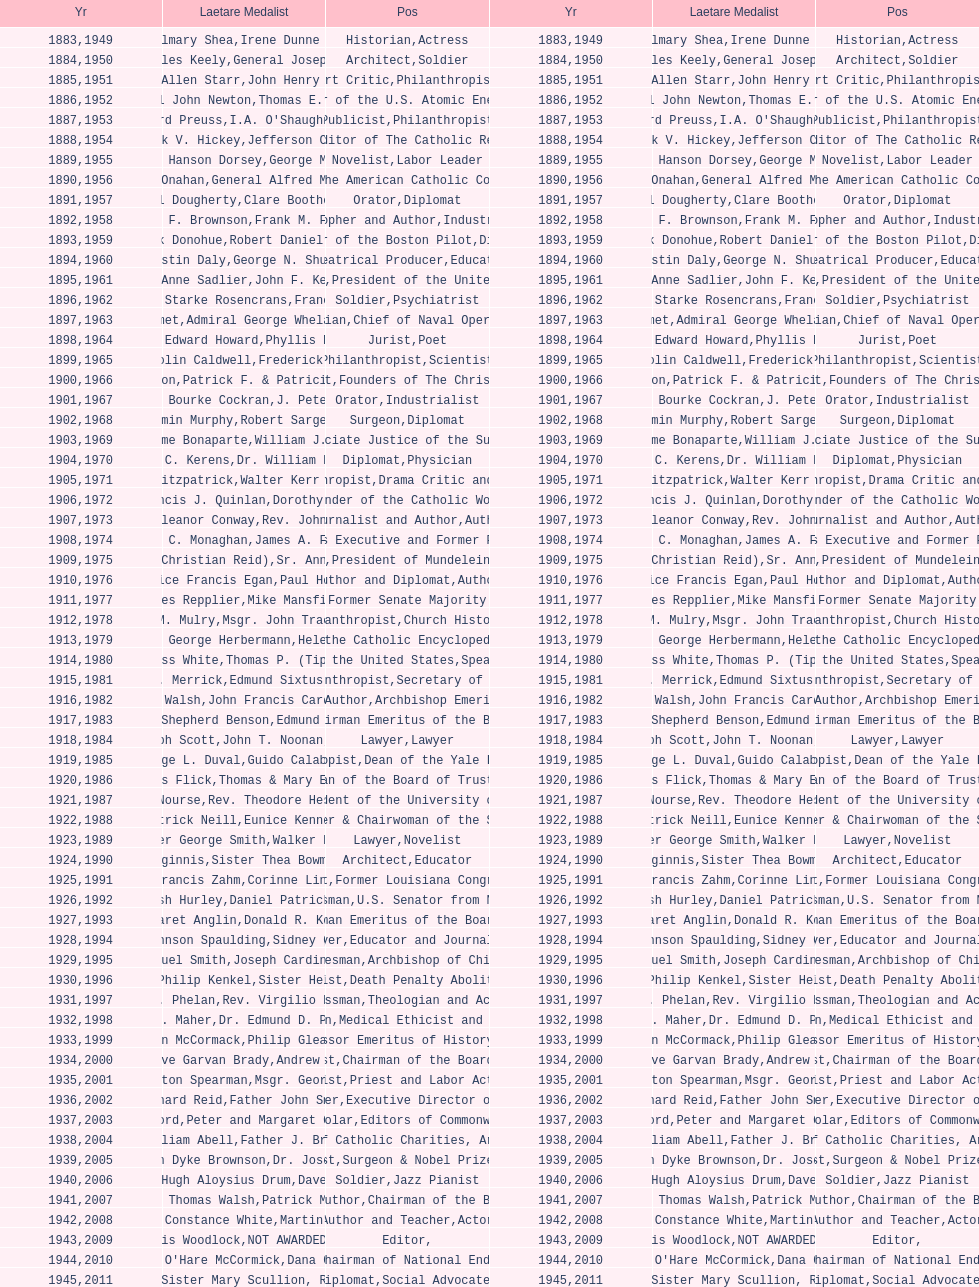What are the number of laetare medalist that held a diplomat position? 8. Could you help me parse every detail presented in this table? {'header': ['Yr', 'Laetare Medalist', 'Pos', 'Yr', 'Laetare Medalist', 'Pos'], 'rows': [['1883', 'John Gilmary Shea', 'Historian', '1949', 'Irene Dunne Griffin', 'Actress'], ['1884', 'Patrick Charles Keely', 'Architect', '1950', 'General Joseph L. Collins', 'Soldier'], ['1885', 'Eliza Allen Starr', 'Art Critic', '1951', 'John Henry Phelan', 'Philanthropist'], ['1886', 'General John Newton', 'Engineer', '1952', 'Thomas E. Murray', 'Member of the U.S. Atomic Energy Commission'], ['1887', 'Edward Preuss', 'Publicist', '1953', "I.A. O'Shaughnessy", 'Philanthropist'], ['1888', 'Patrick V. Hickey', 'Founder and Editor of The Catholic Review', '1954', 'Jefferson Caffery', 'Diplomat'], ['1889', 'Anna Hanson Dorsey', 'Novelist', '1955', 'George Meany', 'Labor Leader'], ['1890', 'William J. Onahan', 'Organizer of the American Catholic Congress', '1956', 'General Alfred M. Gruenther', 'Soldier'], ['1891', 'Daniel Dougherty', 'Orator', '1957', 'Clare Boothe Luce', 'Diplomat'], ['1892', 'Henry F. Brownson', 'Philosopher and Author', '1958', 'Frank M. Folsom', 'Industrialist'], ['1893', 'Patrick Donohue', 'Founder of the Boston Pilot', '1959', 'Robert Daniel Murphy', 'Diplomat'], ['1894', 'Augustin Daly', 'Theatrical Producer', '1960', 'George N. Shuster', 'Educator'], ['1895', 'Mary Anne Sadlier', 'Novelist', '1961', 'John F. Kennedy', 'President of the United States'], ['1896', 'General William Starke Rosencrans', 'Soldier', '1962', 'Francis J. Braceland', 'Psychiatrist'], ['1897', 'Thomas Addis Emmet', 'Physician', '1963', 'Admiral George Whelan Anderson, Jr.', 'Chief of Naval Operations'], ['1898', 'Timothy Edward Howard', 'Jurist', '1964', 'Phyllis McGinley', 'Poet'], ['1899', 'Mary Gwendolin Caldwell', 'Philanthropist', '1965', 'Frederick D. Rossini', 'Scientist'], ['1900', 'John A. Creighton', 'Philanthropist', '1966', 'Patrick F. & Patricia Caron Crowley', 'Founders of The Christian Movement'], ['1901', 'William Bourke Cockran', 'Orator', '1967', 'J. Peter Grace', 'Industrialist'], ['1902', 'John Benjamin Murphy', 'Surgeon', '1968', 'Robert Sargent Shriver', 'Diplomat'], ['1903', 'Charles Jerome Bonaparte', 'Lawyer', '1969', 'William J. Brennan Jr.', 'Associate Justice of the Supreme Court'], ['1904', 'Richard C. Kerens', 'Diplomat', '1970', 'Dr. William B. Walsh', 'Physician'], ['1905', 'Thomas B. Fitzpatrick', 'Philanthropist', '1971', 'Walter Kerr & Jean Kerr', 'Drama Critic and Author'], ['1906', 'Francis J. Quinlan', 'Physician', '1972', 'Dorothy Day', 'Founder of the Catholic Worker Movement'], ['1907', 'Katherine Eleanor Conway', 'Journalist and Author', '1973', "Rev. John A. O'Brien", 'Author'], ['1908', 'James C. Monaghan', 'Economist', '1974', 'James A. Farley', 'Business Executive and Former Postmaster General'], ['1909', 'Frances Tieran (Christian Reid)', 'Novelist', '1975', 'Sr. Ann Ida Gannon, BMV', 'President of Mundelein College'], ['1910', 'Maurice Francis Egan', 'Author and Diplomat', '1976', 'Paul Horgan', 'Author'], ['1911', 'Agnes Repplier', 'Author', '1977', 'Mike Mansfield', 'Former Senate Majority Leader'], ['1912', 'Thomas M. Mulry', 'Philanthropist', '1978', 'Msgr. John Tracy Ellis', 'Church Historian'], ['1913', 'Charles George Herbermann', 'Editor of the Catholic Encyclopedia', '1979', 'Helen Hayes', 'Actress'], ['1914', 'Edward Douglass White', 'Chief Justice of the United States', '1980', "Thomas P. (Tip) O'Neill Jr.", 'Speaker of the House'], ['1915', 'Mary V. Merrick', 'Philanthropist', '1981', 'Edmund Sixtus Muskie', 'Secretary of State'], ['1916', 'James Joseph Walsh', 'Physician and Author', '1982', 'John Francis Cardinal Dearden', 'Archbishop Emeritus of Detroit'], ['1917', 'Admiral William Shepherd Benson', 'Chief of Naval Operations', '1983', 'Edmund & Evelyn Stephan', 'Chairman Emeritus of the Board of Trustees and his wife'], ['1918', 'Joseph Scott', 'Lawyer', '1984', 'John T. Noonan, Jr.', 'Lawyer'], ['1919', 'George L. Duval', 'Philanthropist', '1985', 'Guido Calabresi', 'Dean of the Yale Law School'], ['1920', 'Lawrence Francis Flick', 'Physician', '1986', 'Thomas & Mary Elizabeth Carney', 'Chairman of the Board of Trustees and his wife'], ['1921', 'Elizabeth Nourse', 'Artist', '1987', 'Rev. Theodore Hesburgh, CSC', 'President of the University of Notre Dame'], ['1922', 'Charles Patrick Neill', 'Economist', '1988', 'Eunice Kennedy Shriver', 'Founder & Chairwoman of the Special Olympics'], ['1923', 'Walter George Smith', 'Lawyer', '1989', 'Walker Percy', 'Novelist'], ['1924', 'Charles Donagh Maginnis', 'Architect', '1990', 'Sister Thea Bowman (posthumously)', 'Educator'], ['1925', 'Albert Francis Zahm', 'Scientist', '1991', 'Corinne Lindy Boggs', 'Former Louisiana Congresswoman'], ['1926', 'Edward Nash Hurley', 'Businessman', '1992', 'Daniel Patrick Moynihan', 'U.S. Senator from New York'], ['1927', 'Margaret Anglin', 'Actress', '1993', 'Donald R. Keough', 'Chairman Emeritus of the Board of Trustees'], ['1928', 'John Johnson Spaulding', 'Lawyer', '1994', 'Sidney Callahan', 'Educator and Journalist'], ['1929', 'Alfred Emmanuel Smith', 'Statesman', '1995', 'Joseph Cardinal Bernardin', 'Archbishop of Chicago'], ['1930', 'Frederick Philip Kenkel', 'Publicist', '1996', 'Sister Helen Prejean', 'Death Penalty Abolitionist'], ['1931', 'James J. Phelan', 'Businessman', '1997', 'Rev. Virgilio Elizondo', 'Theologian and Activist'], ['1932', 'Stephen J. Maher', 'Physician', '1998', 'Dr. Edmund D. Pellegrino', 'Medical Ethicist and Educator'], ['1933', 'John McCormack', 'Artist', '1999', 'Philip Gleason', 'Professor Emeritus of History, Notre Dame'], ['1934', 'Genevieve Garvan Brady', 'Philanthropist', '2000', 'Andrew McKenna', 'Chairman of the Board of Trustees'], ['1935', 'Francis Hamilton Spearman', 'Novelist', '2001', 'Msgr. George G. Higgins', 'Priest and Labor Activist'], ['1936', 'Richard Reid', 'Journalist and Lawyer', '2002', 'Father John Smyth', 'Executive Director of Maryville Academy'], ['1937', 'Jeremiah D. M. Ford', 'Scholar', '2003', "Peter and Margaret O'Brien Steinfels", 'Editors of Commonweal'], ['1938', 'Irvin William Abell', 'Surgeon', '2004', 'Father J. Bryan Hehir', 'President of Catholic Charities, Archdiocese of Boston'], ['1939', 'Josephine Van Dyke Brownson', 'Catechist', '2005', 'Dr. Joseph E. Murray', 'Surgeon & Nobel Prize Winner'], ['1940', 'General Hugh Aloysius Drum', 'Soldier', '2006', 'Dave Brubeck', 'Jazz Pianist'], ['1941', 'William Thomas Walsh', 'Journalist and Author', '2007', 'Patrick McCartan', 'Chairman of the Board of Trustees'], ['1942', 'Helen Constance White', 'Author and Teacher', '2008', 'Martin Sheen', 'Actor'], ['1943', 'Thomas Francis Woodlock', 'Editor', '2009', 'NOT AWARDED (SEE BELOW)', ''], ['1944', "Anne O'Hare McCormick", 'Journalist', '2010', 'Dana Gioia', 'Former Chairman of National Endowment for the Arts'], ['1945', 'Gardiner Howland Shaw', 'Diplomat', '2011', 'Sister Mary Scullion, R.S.M., & Joan McConnon', 'Social Advocates'], ['1946', 'Carlton J. H. Hayes', 'Historian and Diplomat', '2012', 'Ken Hackett', 'Former President of Catholic Relief Services'], ['1947', 'William G. Bruce', 'Publisher and Civic Leader', '2013', 'Sister Susanne Gallagher, S.P.\\nSister Mary Therese Harrington, S.H.\\nRev. James H. McCarthy', 'Founders of S.P.R.E.D. (Special Religious Education Development Network)'], ['1948', 'Frank C. Walker', 'Postmaster General and Civic Leader', '2014', 'Kenneth R. Miller', 'Professor of Biology at Brown University']]} 